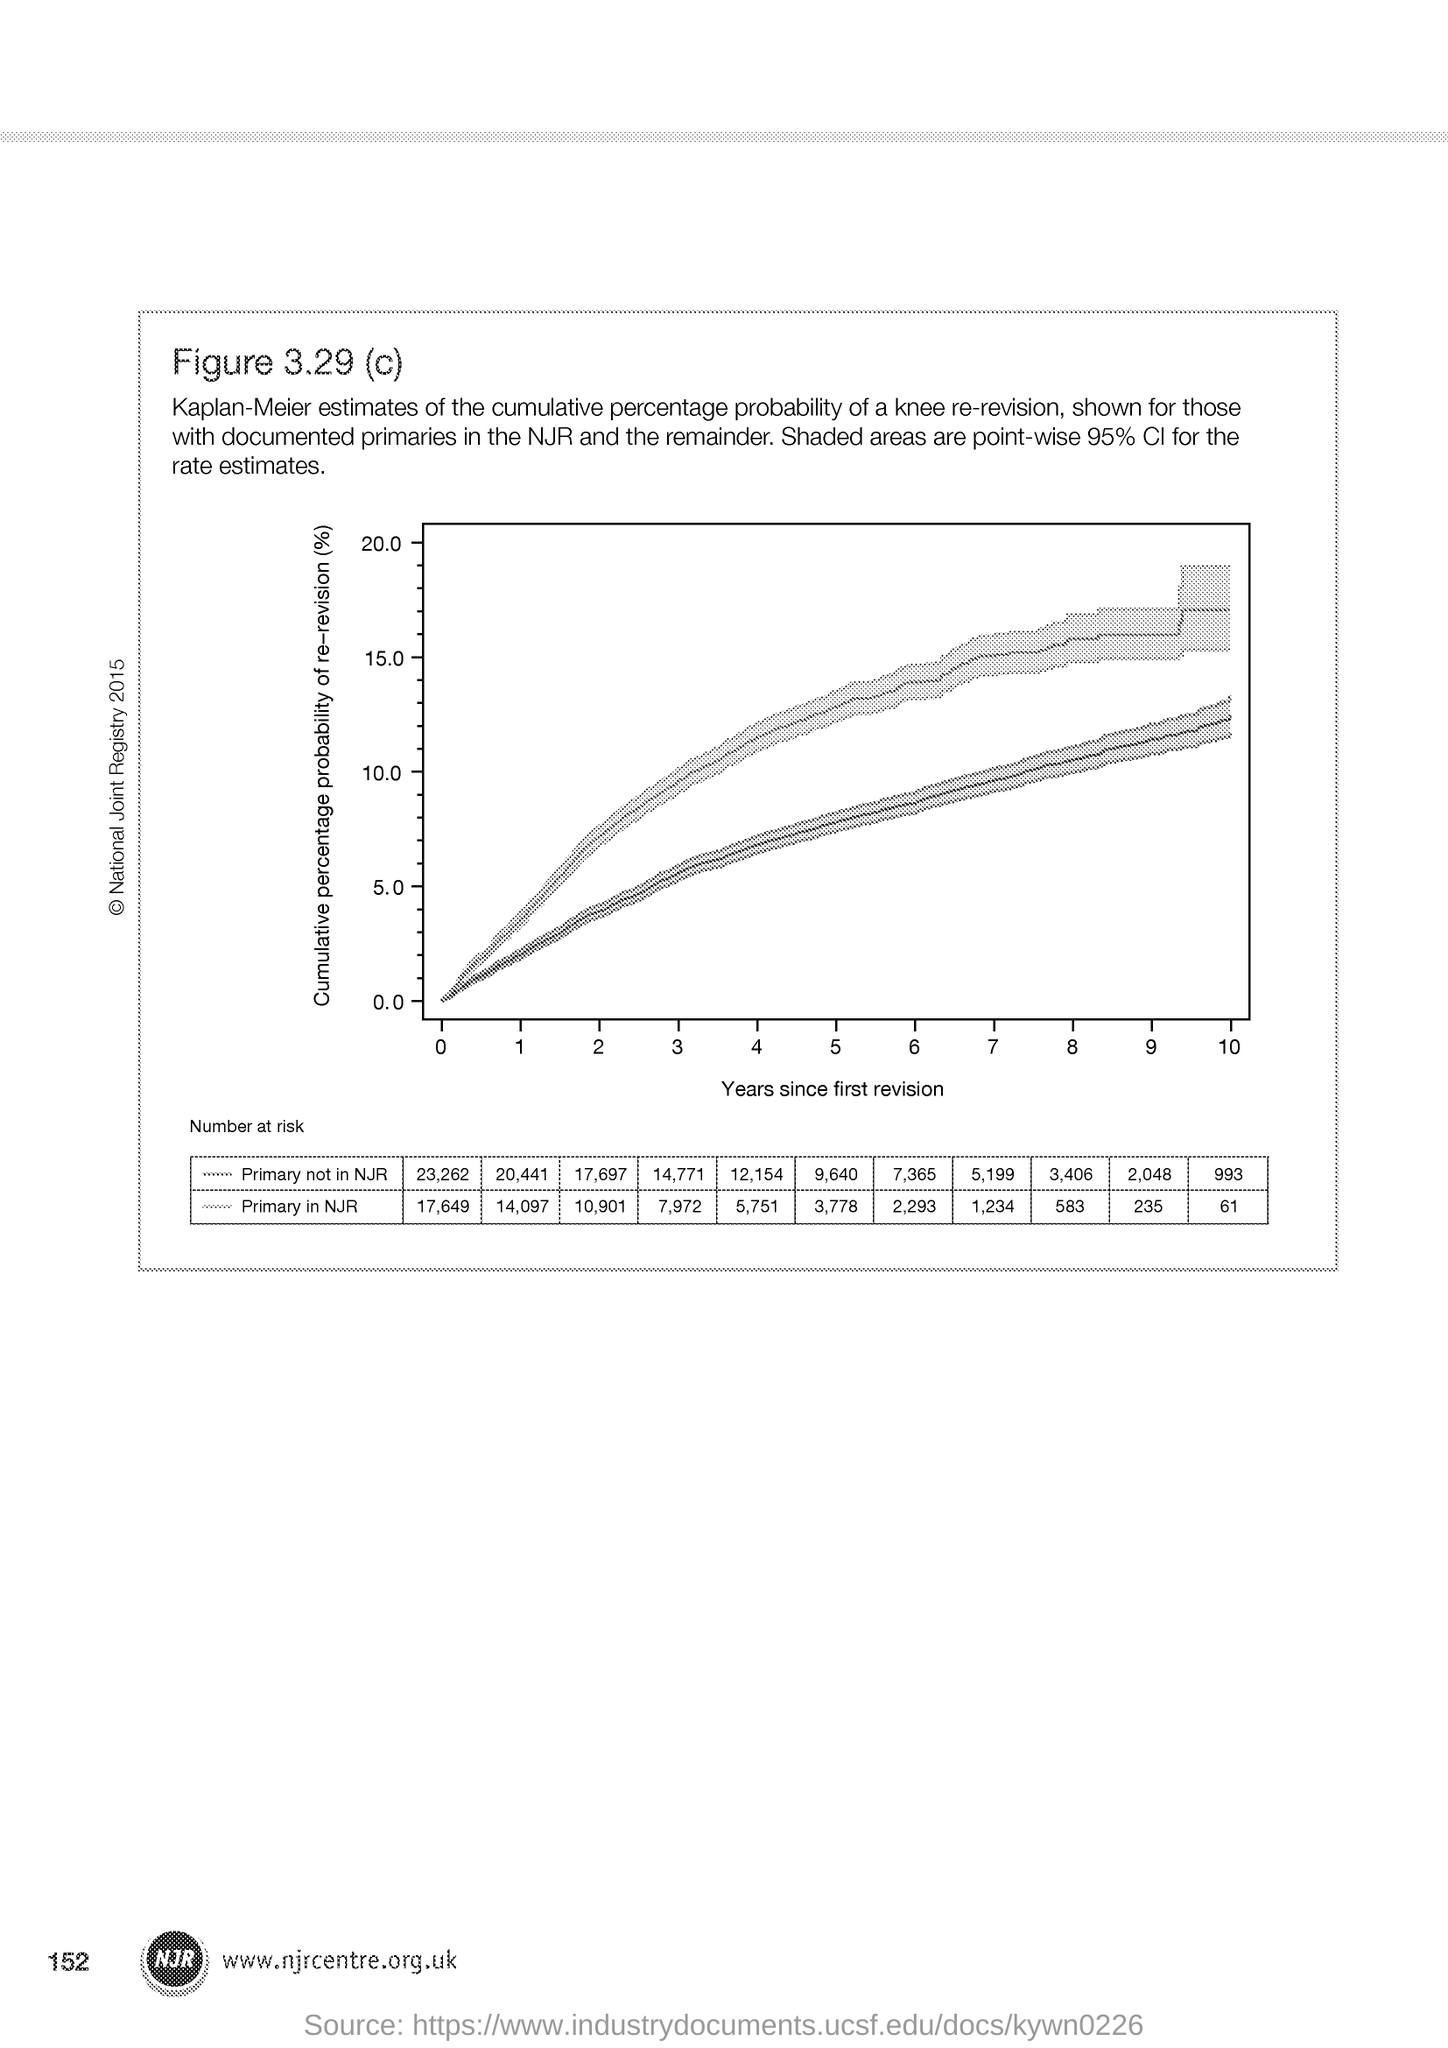What is plotted in the x-axis ?
Keep it short and to the point. Years since first revision. What is the Page Number?
Provide a succinct answer. 152. 